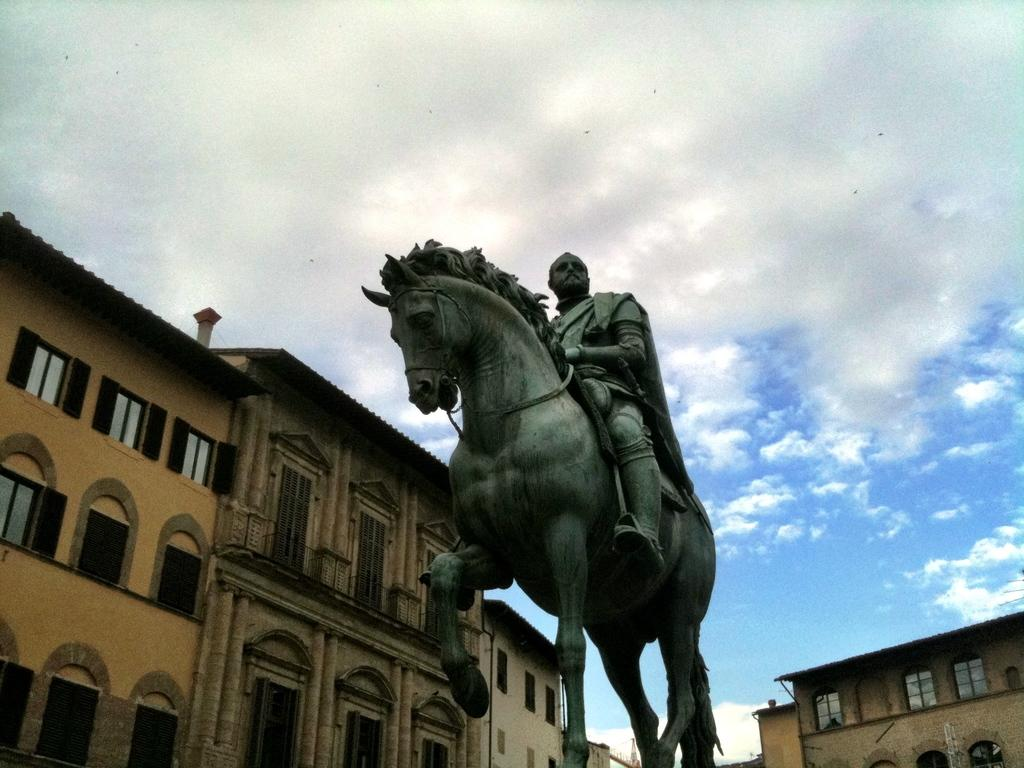What is the main subject of the image? There is a statue of a person in the image. What is the statue doing? The statue depicts the person sitting on an animal. What can be seen in the background of the image? There are buildings and clouds visible in the background of the image. What color is the sky in the background of the image? The sky is blue in the background of the image. What type of dog can be heard barking in the image? There is no dog present in the image, and therefore no barking can be heard. 